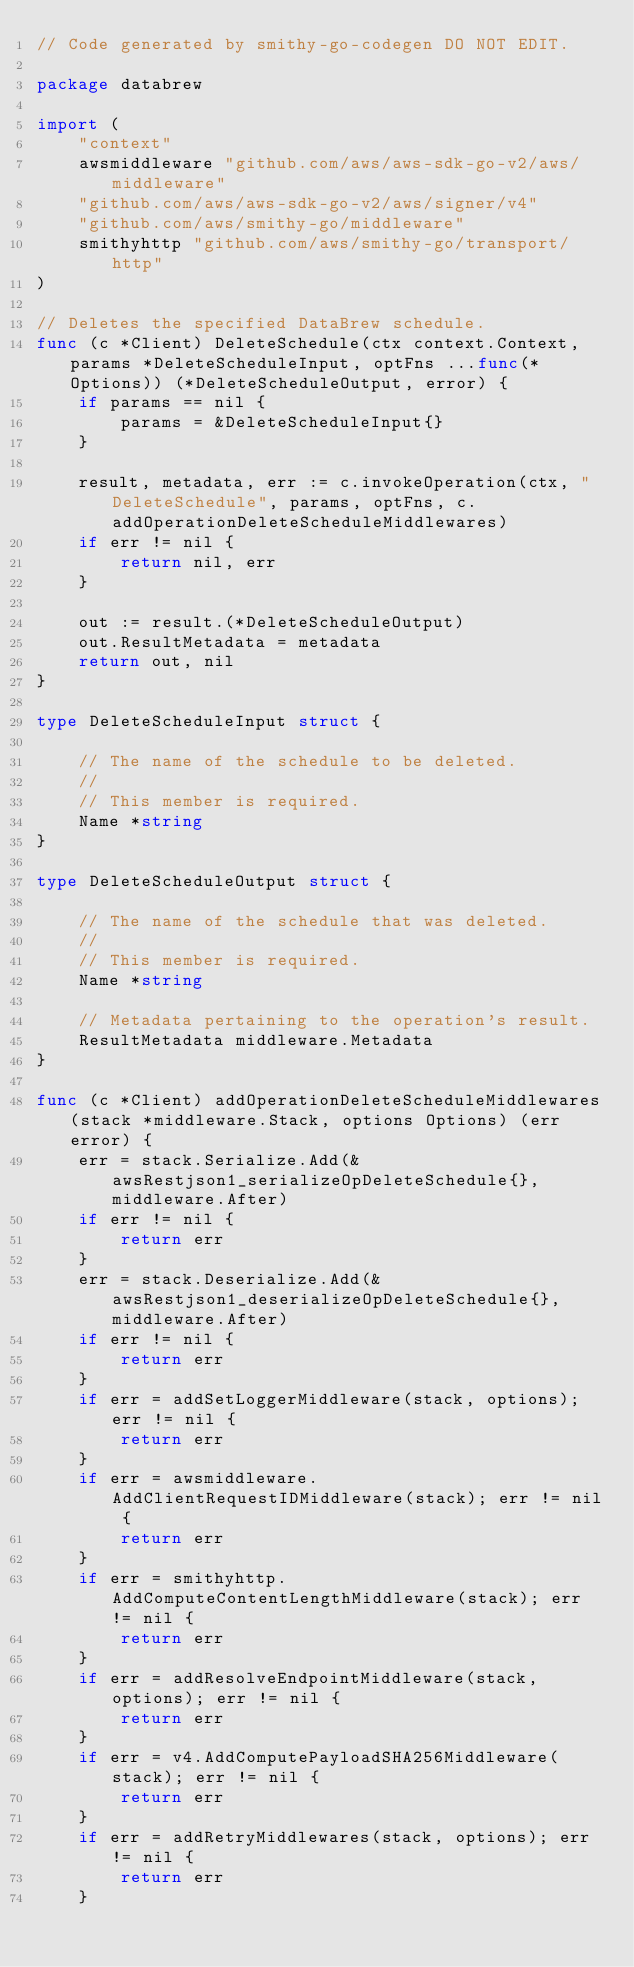Convert code to text. <code><loc_0><loc_0><loc_500><loc_500><_Go_>// Code generated by smithy-go-codegen DO NOT EDIT.

package databrew

import (
	"context"
	awsmiddleware "github.com/aws/aws-sdk-go-v2/aws/middleware"
	"github.com/aws/aws-sdk-go-v2/aws/signer/v4"
	"github.com/aws/smithy-go/middleware"
	smithyhttp "github.com/aws/smithy-go/transport/http"
)

// Deletes the specified DataBrew schedule.
func (c *Client) DeleteSchedule(ctx context.Context, params *DeleteScheduleInput, optFns ...func(*Options)) (*DeleteScheduleOutput, error) {
	if params == nil {
		params = &DeleteScheduleInput{}
	}

	result, metadata, err := c.invokeOperation(ctx, "DeleteSchedule", params, optFns, c.addOperationDeleteScheduleMiddlewares)
	if err != nil {
		return nil, err
	}

	out := result.(*DeleteScheduleOutput)
	out.ResultMetadata = metadata
	return out, nil
}

type DeleteScheduleInput struct {

	// The name of the schedule to be deleted.
	//
	// This member is required.
	Name *string
}

type DeleteScheduleOutput struct {

	// The name of the schedule that was deleted.
	//
	// This member is required.
	Name *string

	// Metadata pertaining to the operation's result.
	ResultMetadata middleware.Metadata
}

func (c *Client) addOperationDeleteScheduleMiddlewares(stack *middleware.Stack, options Options) (err error) {
	err = stack.Serialize.Add(&awsRestjson1_serializeOpDeleteSchedule{}, middleware.After)
	if err != nil {
		return err
	}
	err = stack.Deserialize.Add(&awsRestjson1_deserializeOpDeleteSchedule{}, middleware.After)
	if err != nil {
		return err
	}
	if err = addSetLoggerMiddleware(stack, options); err != nil {
		return err
	}
	if err = awsmiddleware.AddClientRequestIDMiddleware(stack); err != nil {
		return err
	}
	if err = smithyhttp.AddComputeContentLengthMiddleware(stack); err != nil {
		return err
	}
	if err = addResolveEndpointMiddleware(stack, options); err != nil {
		return err
	}
	if err = v4.AddComputePayloadSHA256Middleware(stack); err != nil {
		return err
	}
	if err = addRetryMiddlewares(stack, options); err != nil {
		return err
	}</code> 